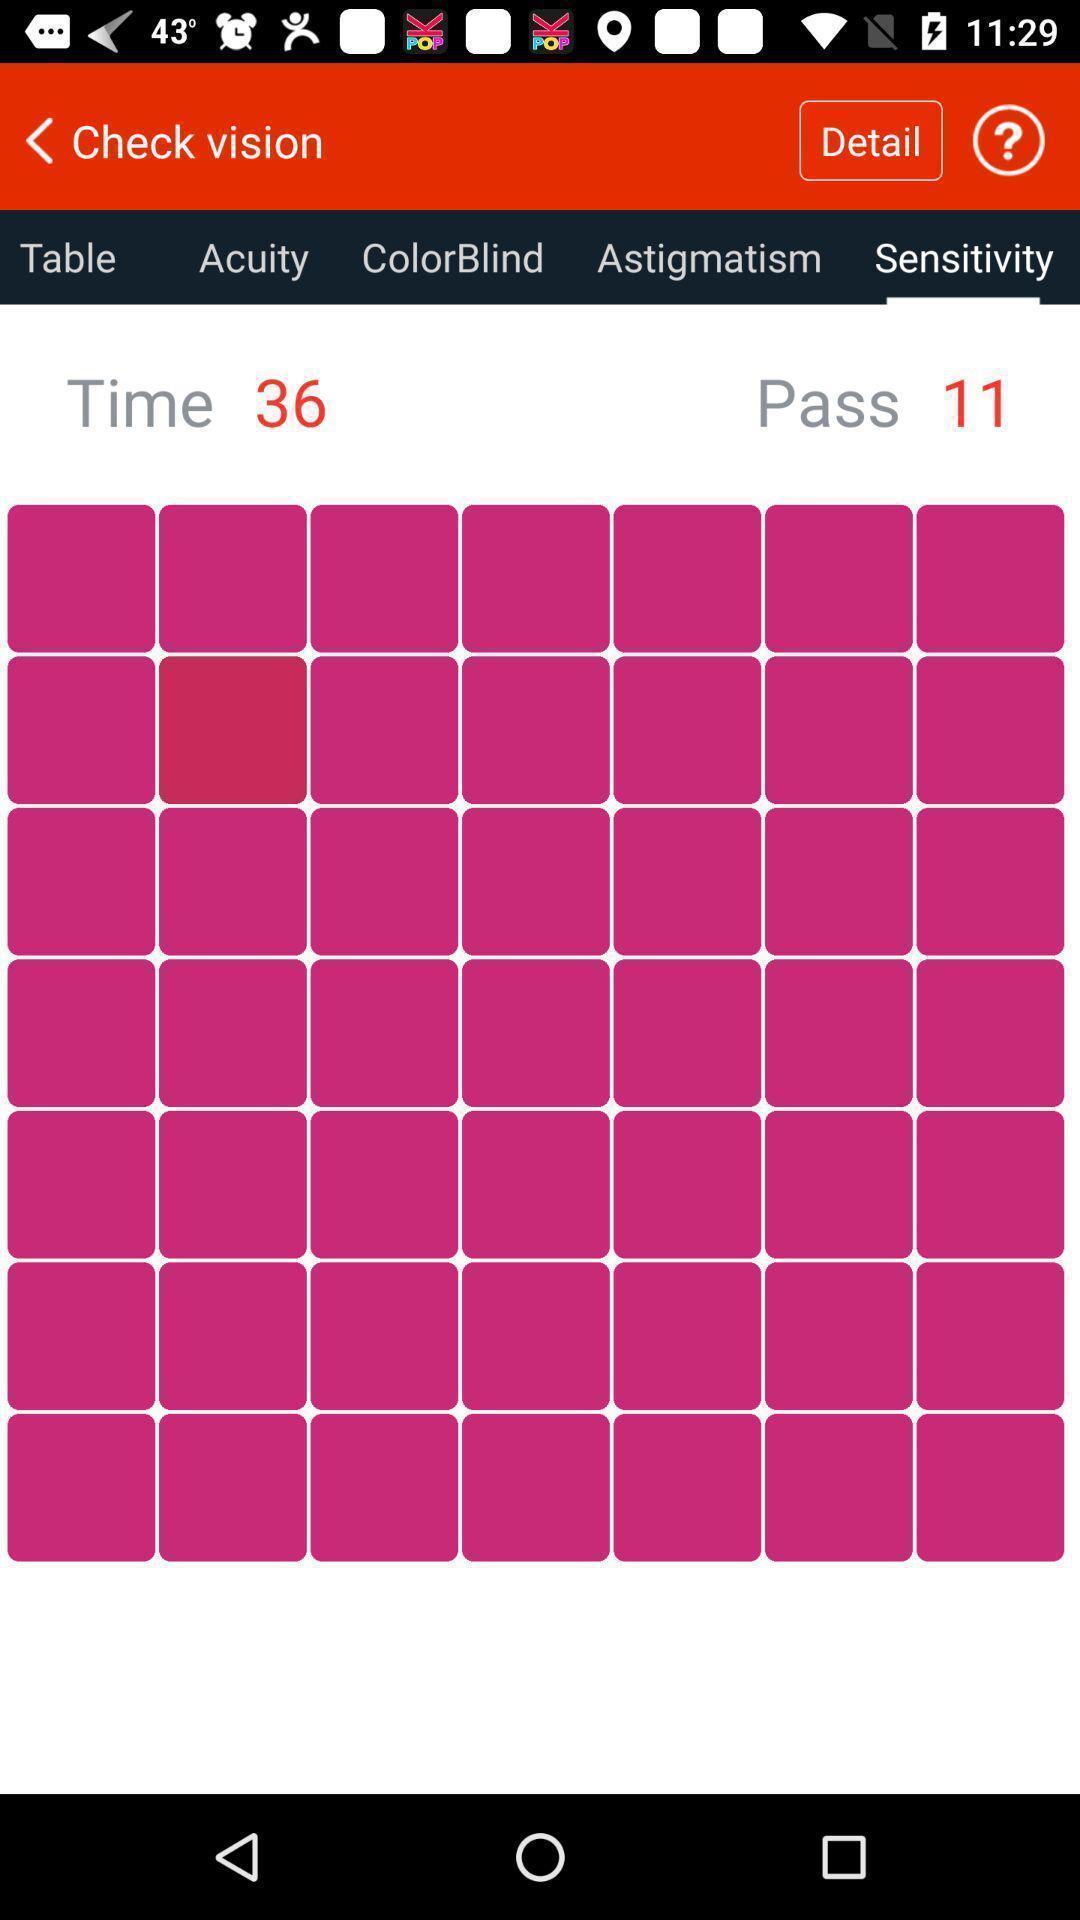Tell me what you see in this picture. Screen displaying multiple vision options. 